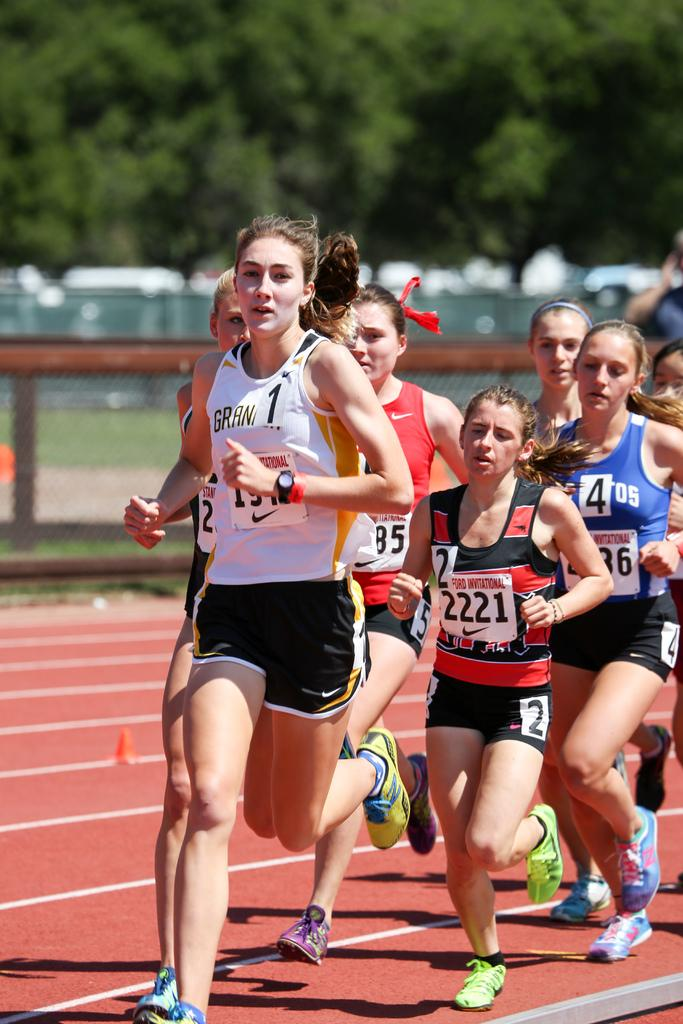<image>
Give a short and clear explanation of the subsequent image. A runner with no. 1 on her left chest is leading the pack of runners. 